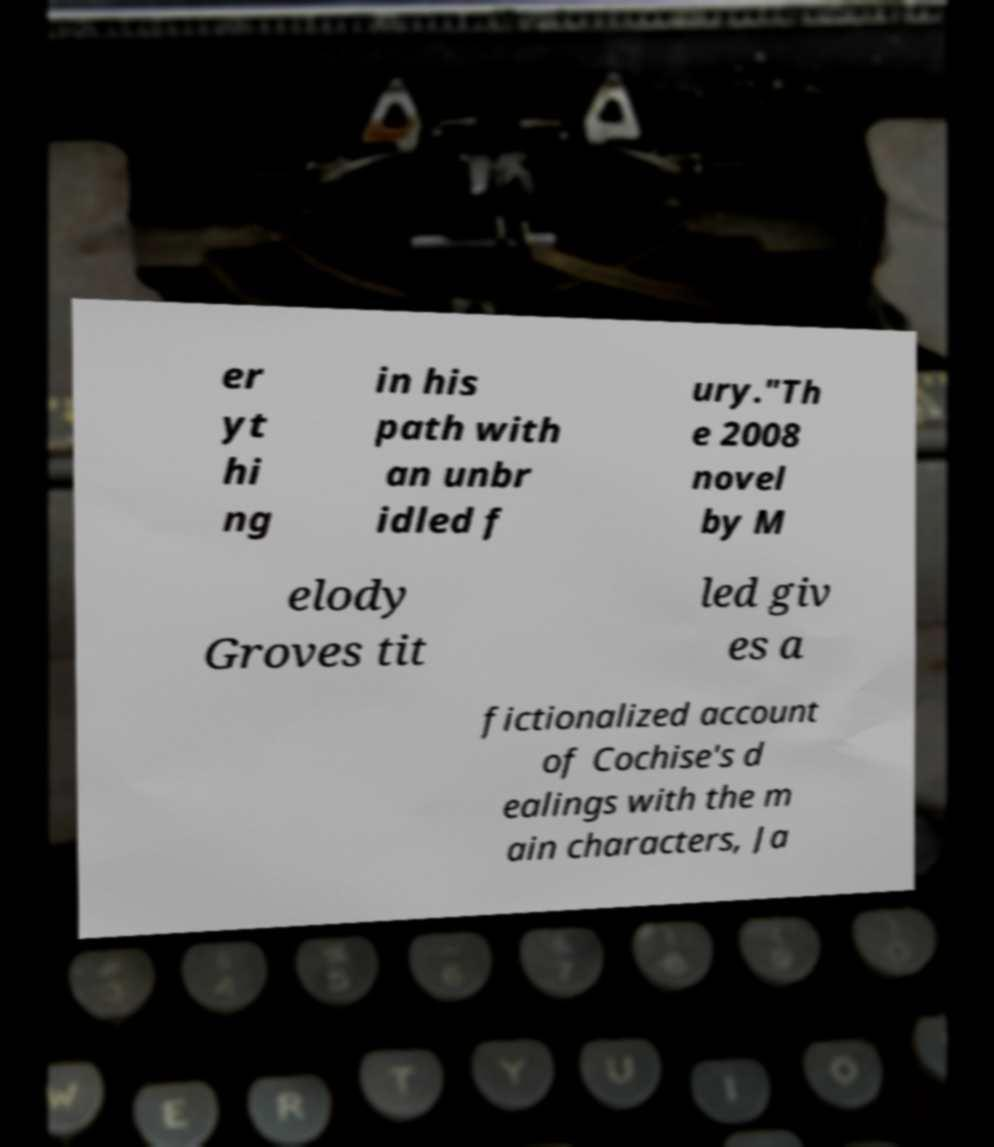Could you extract and type out the text from this image? er yt hi ng in his path with an unbr idled f ury."Th e 2008 novel by M elody Groves tit led giv es a fictionalized account of Cochise's d ealings with the m ain characters, Ja 